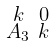Convert formula to latex. <formula><loc_0><loc_0><loc_500><loc_500>\begin{smallmatrix} k & 0 \\ A _ { 3 } & k \end{smallmatrix}</formula> 